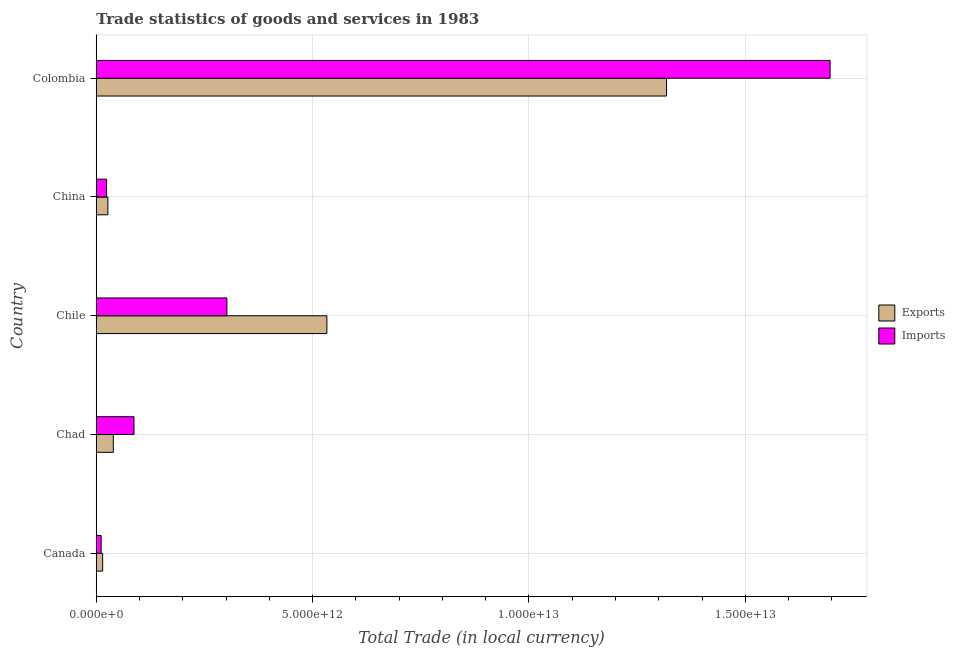How many different coloured bars are there?
Provide a succinct answer. 2. Are the number of bars per tick equal to the number of legend labels?
Ensure brevity in your answer.  Yes. How many bars are there on the 4th tick from the top?
Your response must be concise. 2. How many bars are there on the 4th tick from the bottom?
Your answer should be compact. 2. What is the label of the 4th group of bars from the top?
Keep it short and to the point. Chad. In how many cases, is the number of bars for a given country not equal to the number of legend labels?
Offer a very short reply. 0. What is the export of goods and services in Chad?
Provide a short and direct response. 3.94e+11. Across all countries, what is the maximum imports of goods and services?
Keep it short and to the point. 1.70e+13. Across all countries, what is the minimum imports of goods and services?
Provide a short and direct response. 1.13e+11. In which country was the export of goods and services maximum?
Make the answer very short. Colombia. What is the total export of goods and services in the graph?
Provide a short and direct response. 1.93e+13. What is the difference between the export of goods and services in Chad and that in Chile?
Give a very brief answer. -4.94e+12. What is the difference between the imports of goods and services in Colombia and the export of goods and services in Chad?
Your answer should be very brief. 1.66e+13. What is the average imports of goods and services per country?
Give a very brief answer. 4.24e+12. What is the difference between the imports of goods and services and export of goods and services in Chad?
Give a very brief answer. 4.78e+11. In how many countries, is the export of goods and services greater than 15000000000000 LCU?
Offer a very short reply. 0. What is the ratio of the imports of goods and services in Canada to that in China?
Ensure brevity in your answer.  0.47. Is the export of goods and services in Chad less than that in Chile?
Offer a very short reply. Yes. What is the difference between the highest and the second highest imports of goods and services?
Make the answer very short. 1.39e+13. What is the difference between the highest and the lowest export of goods and services?
Your answer should be compact. 1.30e+13. Is the sum of the imports of goods and services in Chad and Chile greater than the maximum export of goods and services across all countries?
Your answer should be very brief. No. What does the 1st bar from the top in Canada represents?
Provide a succinct answer. Imports. What does the 2nd bar from the bottom in Colombia represents?
Offer a very short reply. Imports. How many bars are there?
Provide a succinct answer. 10. Are all the bars in the graph horizontal?
Keep it short and to the point. Yes. How many countries are there in the graph?
Offer a very short reply. 5. What is the difference between two consecutive major ticks on the X-axis?
Your answer should be compact. 5.00e+12. Are the values on the major ticks of X-axis written in scientific E-notation?
Your response must be concise. Yes. Does the graph contain grids?
Your answer should be compact. Yes. Where does the legend appear in the graph?
Your response must be concise. Center right. What is the title of the graph?
Provide a short and direct response. Trade statistics of goods and services in 1983. What is the label or title of the X-axis?
Ensure brevity in your answer.  Total Trade (in local currency). What is the label or title of the Y-axis?
Keep it short and to the point. Country. What is the Total Trade (in local currency) of Exports in Canada?
Ensure brevity in your answer.  1.48e+11. What is the Total Trade (in local currency) in Imports in Canada?
Provide a short and direct response. 1.13e+11. What is the Total Trade (in local currency) of Exports in Chad?
Your answer should be very brief. 3.94e+11. What is the Total Trade (in local currency) in Imports in Chad?
Your answer should be very brief. 8.72e+11. What is the Total Trade (in local currency) of Exports in Chile?
Ensure brevity in your answer.  5.33e+12. What is the Total Trade (in local currency) of Imports in Chile?
Offer a terse response. 3.02e+12. What is the Total Trade (in local currency) of Exports in China?
Give a very brief answer. 2.68e+11. What is the Total Trade (in local currency) of Imports in China?
Make the answer very short. 2.39e+11. What is the Total Trade (in local currency) in Exports in Colombia?
Offer a terse response. 1.32e+13. What is the Total Trade (in local currency) of Imports in Colombia?
Offer a very short reply. 1.70e+13. Across all countries, what is the maximum Total Trade (in local currency) in Exports?
Provide a succinct answer. 1.32e+13. Across all countries, what is the maximum Total Trade (in local currency) of Imports?
Your answer should be very brief. 1.70e+13. Across all countries, what is the minimum Total Trade (in local currency) of Exports?
Provide a succinct answer. 1.48e+11. Across all countries, what is the minimum Total Trade (in local currency) in Imports?
Offer a very short reply. 1.13e+11. What is the total Total Trade (in local currency) of Exports in the graph?
Your answer should be very brief. 1.93e+13. What is the total Total Trade (in local currency) of Imports in the graph?
Provide a succinct answer. 2.12e+13. What is the difference between the Total Trade (in local currency) in Exports in Canada and that in Chad?
Your response must be concise. -2.46e+11. What is the difference between the Total Trade (in local currency) of Imports in Canada and that in Chad?
Offer a terse response. -7.59e+11. What is the difference between the Total Trade (in local currency) in Exports in Canada and that in Chile?
Your answer should be very brief. -5.18e+12. What is the difference between the Total Trade (in local currency) of Imports in Canada and that in Chile?
Ensure brevity in your answer.  -2.91e+12. What is the difference between the Total Trade (in local currency) in Exports in Canada and that in China?
Provide a short and direct response. -1.20e+11. What is the difference between the Total Trade (in local currency) in Imports in Canada and that in China?
Provide a succinct answer. -1.26e+11. What is the difference between the Total Trade (in local currency) of Exports in Canada and that in Colombia?
Ensure brevity in your answer.  -1.30e+13. What is the difference between the Total Trade (in local currency) of Imports in Canada and that in Colombia?
Provide a short and direct response. -1.68e+13. What is the difference between the Total Trade (in local currency) of Exports in Chad and that in Chile?
Offer a very short reply. -4.94e+12. What is the difference between the Total Trade (in local currency) of Imports in Chad and that in Chile?
Give a very brief answer. -2.15e+12. What is the difference between the Total Trade (in local currency) in Exports in Chad and that in China?
Make the answer very short. 1.26e+11. What is the difference between the Total Trade (in local currency) in Imports in Chad and that in China?
Provide a succinct answer. 6.34e+11. What is the difference between the Total Trade (in local currency) in Exports in Chad and that in Colombia?
Provide a short and direct response. -1.28e+13. What is the difference between the Total Trade (in local currency) in Imports in Chad and that in Colombia?
Offer a terse response. -1.61e+13. What is the difference between the Total Trade (in local currency) of Exports in Chile and that in China?
Keep it short and to the point. 5.06e+12. What is the difference between the Total Trade (in local currency) of Imports in Chile and that in China?
Provide a short and direct response. 2.78e+12. What is the difference between the Total Trade (in local currency) in Exports in Chile and that in Colombia?
Your answer should be compact. -7.85e+12. What is the difference between the Total Trade (in local currency) of Imports in Chile and that in Colombia?
Make the answer very short. -1.39e+13. What is the difference between the Total Trade (in local currency) in Exports in China and that in Colombia?
Give a very brief answer. -1.29e+13. What is the difference between the Total Trade (in local currency) of Imports in China and that in Colombia?
Keep it short and to the point. -1.67e+13. What is the difference between the Total Trade (in local currency) in Exports in Canada and the Total Trade (in local currency) in Imports in Chad?
Ensure brevity in your answer.  -7.24e+11. What is the difference between the Total Trade (in local currency) in Exports in Canada and the Total Trade (in local currency) in Imports in Chile?
Your response must be concise. -2.87e+12. What is the difference between the Total Trade (in local currency) in Exports in Canada and the Total Trade (in local currency) in Imports in China?
Your answer should be very brief. -9.06e+1. What is the difference between the Total Trade (in local currency) in Exports in Canada and the Total Trade (in local currency) in Imports in Colombia?
Offer a terse response. -1.68e+13. What is the difference between the Total Trade (in local currency) of Exports in Chad and the Total Trade (in local currency) of Imports in Chile?
Keep it short and to the point. -2.63e+12. What is the difference between the Total Trade (in local currency) of Exports in Chad and the Total Trade (in local currency) of Imports in China?
Make the answer very short. 1.56e+11. What is the difference between the Total Trade (in local currency) in Exports in Chad and the Total Trade (in local currency) in Imports in Colombia?
Your response must be concise. -1.66e+13. What is the difference between the Total Trade (in local currency) in Exports in Chile and the Total Trade (in local currency) in Imports in China?
Ensure brevity in your answer.  5.09e+12. What is the difference between the Total Trade (in local currency) of Exports in Chile and the Total Trade (in local currency) of Imports in Colombia?
Your response must be concise. -1.16e+13. What is the difference between the Total Trade (in local currency) of Exports in China and the Total Trade (in local currency) of Imports in Colombia?
Your response must be concise. -1.67e+13. What is the average Total Trade (in local currency) of Exports per country?
Make the answer very short. 3.86e+12. What is the average Total Trade (in local currency) in Imports per country?
Make the answer very short. 4.24e+12. What is the difference between the Total Trade (in local currency) in Exports and Total Trade (in local currency) in Imports in Canada?
Offer a very short reply. 3.50e+1. What is the difference between the Total Trade (in local currency) in Exports and Total Trade (in local currency) in Imports in Chad?
Offer a terse response. -4.78e+11. What is the difference between the Total Trade (in local currency) in Exports and Total Trade (in local currency) in Imports in Chile?
Ensure brevity in your answer.  2.31e+12. What is the difference between the Total Trade (in local currency) of Exports and Total Trade (in local currency) of Imports in China?
Ensure brevity in your answer.  2.97e+1. What is the difference between the Total Trade (in local currency) in Exports and Total Trade (in local currency) in Imports in Colombia?
Offer a terse response. -3.78e+12. What is the ratio of the Total Trade (in local currency) in Exports in Canada to that in Chad?
Your answer should be very brief. 0.38. What is the ratio of the Total Trade (in local currency) of Imports in Canada to that in Chad?
Provide a short and direct response. 0.13. What is the ratio of the Total Trade (in local currency) of Exports in Canada to that in Chile?
Ensure brevity in your answer.  0.03. What is the ratio of the Total Trade (in local currency) of Imports in Canada to that in Chile?
Make the answer very short. 0.04. What is the ratio of the Total Trade (in local currency) in Exports in Canada to that in China?
Your response must be concise. 0.55. What is the ratio of the Total Trade (in local currency) of Imports in Canada to that in China?
Keep it short and to the point. 0.47. What is the ratio of the Total Trade (in local currency) of Exports in Canada to that in Colombia?
Offer a very short reply. 0.01. What is the ratio of the Total Trade (in local currency) in Imports in Canada to that in Colombia?
Your answer should be compact. 0.01. What is the ratio of the Total Trade (in local currency) in Exports in Chad to that in Chile?
Provide a succinct answer. 0.07. What is the ratio of the Total Trade (in local currency) of Imports in Chad to that in Chile?
Provide a short and direct response. 0.29. What is the ratio of the Total Trade (in local currency) in Exports in Chad to that in China?
Offer a very short reply. 1.47. What is the ratio of the Total Trade (in local currency) in Imports in Chad to that in China?
Offer a terse response. 3.66. What is the ratio of the Total Trade (in local currency) in Exports in Chad to that in Colombia?
Provide a succinct answer. 0.03. What is the ratio of the Total Trade (in local currency) in Imports in Chad to that in Colombia?
Make the answer very short. 0.05. What is the ratio of the Total Trade (in local currency) of Exports in Chile to that in China?
Provide a short and direct response. 19.87. What is the ratio of the Total Trade (in local currency) in Imports in Chile to that in China?
Provide a short and direct response. 12.65. What is the ratio of the Total Trade (in local currency) in Exports in Chile to that in Colombia?
Your answer should be very brief. 0.4. What is the ratio of the Total Trade (in local currency) in Imports in Chile to that in Colombia?
Your answer should be very brief. 0.18. What is the ratio of the Total Trade (in local currency) in Exports in China to that in Colombia?
Your response must be concise. 0.02. What is the ratio of the Total Trade (in local currency) of Imports in China to that in Colombia?
Give a very brief answer. 0.01. What is the difference between the highest and the second highest Total Trade (in local currency) in Exports?
Offer a very short reply. 7.85e+12. What is the difference between the highest and the second highest Total Trade (in local currency) in Imports?
Offer a very short reply. 1.39e+13. What is the difference between the highest and the lowest Total Trade (in local currency) in Exports?
Offer a very short reply. 1.30e+13. What is the difference between the highest and the lowest Total Trade (in local currency) of Imports?
Keep it short and to the point. 1.68e+13. 